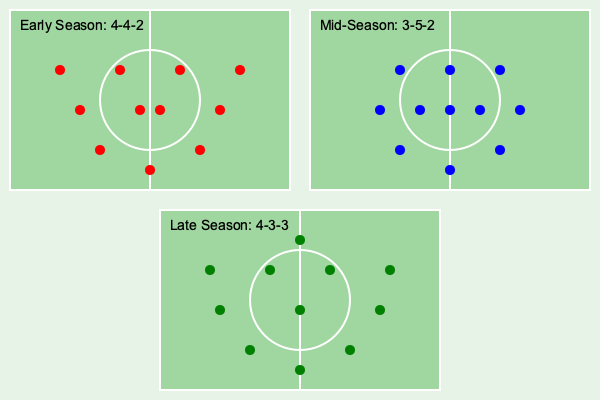During the 1999-2000 National Soccer League season, Canberra Cosmos FC made significant tactical changes. Based on the diagram, which formation did the team adopt in the middle of the season, and how did it differ from their early-season setup in terms of defensive and midfield structures? To answer this question, we need to analyze the tactical diagrams provided for the Canberra Cosmos FC's 1999-2000 National Soccer League season:

1. Early Season Formation (4-4-2):
   - 4 defenders
   - 4 midfielders
   - 2 forwards

2. Mid-Season Formation (3-5-2):
   - 3 defenders
   - 5 midfielders
   - 2 forwards

3. Late Season Formation (4-3-3):
   - 4 defenders
   - 3 midfielders
   - 3 forwards

Comparing the early-season and mid-season formations:

1. Defensive structure:
   - Early season: 4 defenders
   - Mid-season: 3 defenders
   The team reduced the number of defenders by one.

2. Midfield structure:
   - Early season: 4 midfielders
   - Mid-season: 5 midfielders
   The team increased the number of midfielders by one.

3. Forward line:
   - Both formations maintained 2 forwards

The mid-season 3-5-2 formation adopted by Canberra Cosmos FC differed from their early-season 4-4-2 setup by sacrificing a defender to add an extra midfielder. This change likely aimed to strengthen the team's midfield presence, potentially improving ball possession and creating more attacking opportunities through the center of the field.
Answer: 3-5-2; reduced defenders (4 to 3) and increased midfielders (4 to 5) 